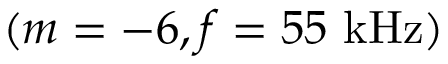<formula> <loc_0><loc_0><loc_500><loc_500>( m = - 6 , f = 5 5 k H z )</formula> 